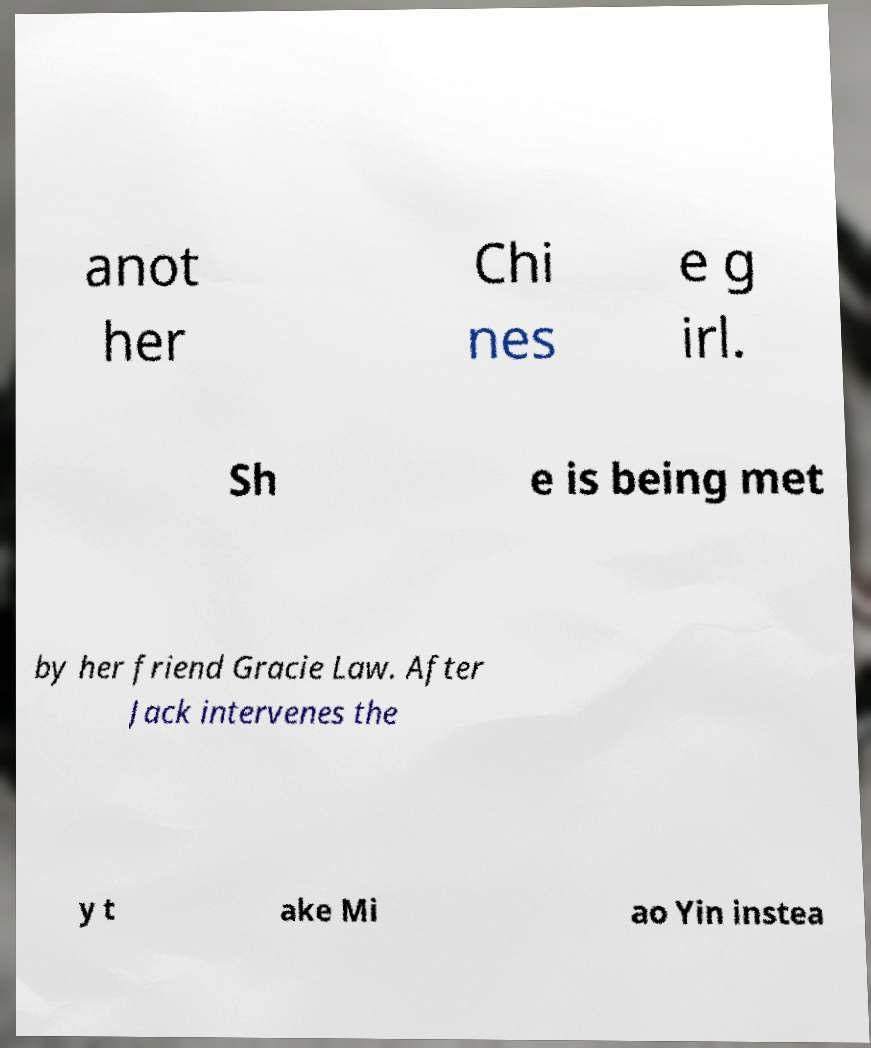Please identify and transcribe the text found in this image. anot her Chi nes e g irl. Sh e is being met by her friend Gracie Law. After Jack intervenes the y t ake Mi ao Yin instea 